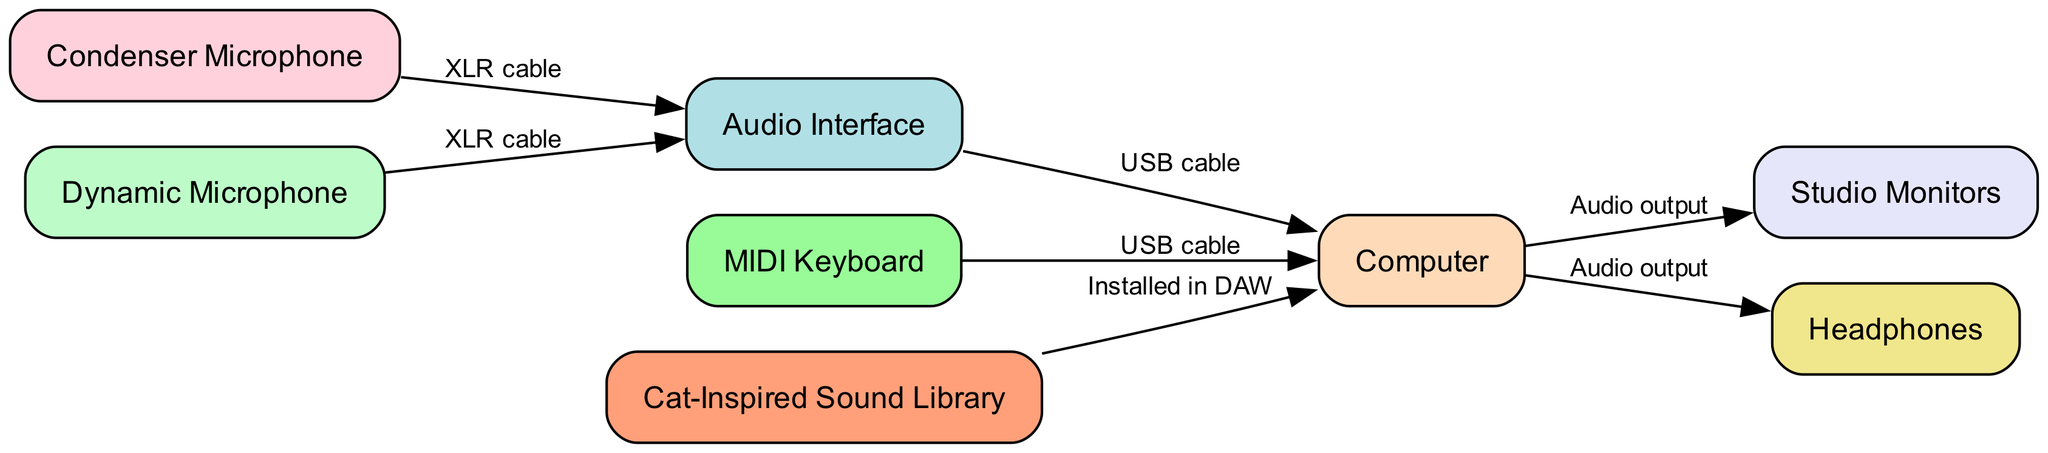What are the types of microphones shown in the diagram? The diagram indicates two types of microphones: a Condenser Microphone and a Dynamic Microphone. These can be identified by their labels in the nodes section of the diagram.
Answer: Condenser Microphone, Dynamic Microphone How many nodes are present in the diagram? The diagram lists 8 distinct nodes, each representing a different component of the recording studio setup, as seen in the nodes section.
Answer: 8 What connects the condenser microphone to the audio interface? An XLR cable connects the condenser microphone to the audio interface, as indicated by the labeled edge between these two nodes.
Answer: XLR cable What is the output of the computer connected to? The computer's output connects to both the studio monitors and headphones, which is shown by the audio output labels on the respective edges from the computer node.
Answer: Studio Monitors, Headphones Which device is directly linked to the MIDI keyboard? The MIDI keyboard is directly linked to the computer, connected by a USB cable, as highlighted in the edge connecting these two nodes.
Answer: Computer What is the purpose of the cat-inspired sound library in the setup? The cat-inspired sound library is installed in the digital audio workstation (DAW) on the computer, demonstrating its functionality as a source of sound for music production.
Answer: Installed in DAW How does the audio interface connect to the computer? The audio interface connects to the computer using a USB cable, as indicated by the label on the edge connecting these two nodes, illustrating how the audio interface sends and receives data from the computer.
Answer: USB cable Which component has two outputs according to the diagram? The computer serves as a component with two outputs, since it connects to both the studio monitors and headphones, as specified by the edges labeled audio output.
Answer: Computer 